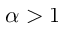<formula> <loc_0><loc_0><loc_500><loc_500>\alpha > 1</formula> 